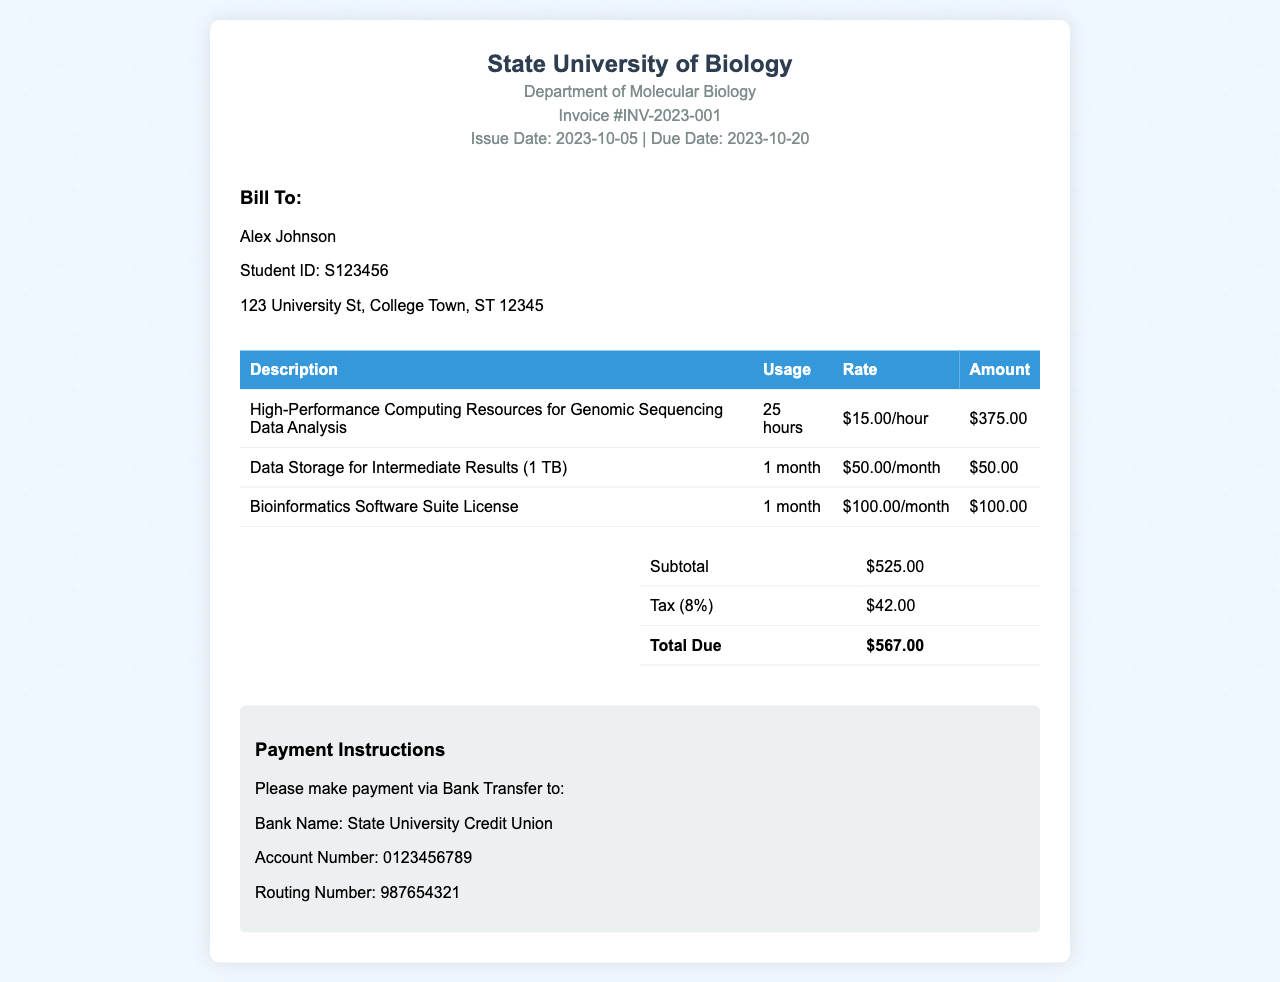what is the invoice number? The invoice number can be found in the header section of the document.
Answer: INV-2023-001 what is the total due amount? The total due amount is calculated in the summary section of the invoice.
Answer: $567.00 who is the invoice billed to? The name of the person the invoice is billed to is in the "Bill To" section.
Answer: Alex Johnson how many hours of high-performance computing were used? The usage hours for high-performance computing resources are listed in the detailed table.
Answer: 25 hours what is the tax rate applied in this invoice? The tax rate can be inferred from the tax amount in relation to the subtotal.
Answer: 8% what is the rate per hour for high-performance computing resources? The rate can be found in the table next to the description of high-performance computing resources.
Answer: $15.00/hour how long is the data storage billed for? The duration for which data storage is billed is specified in the usage column of the invoice.
Answer: 1 month what is the subtotal before tax? The subtotal is mentioned in the summary table of the invoice.
Answer: $525.00 what is the bank name for payment? The bank name is detailed in the payment instructions section at the bottom of the invoice.
Answer: State University Credit Union 